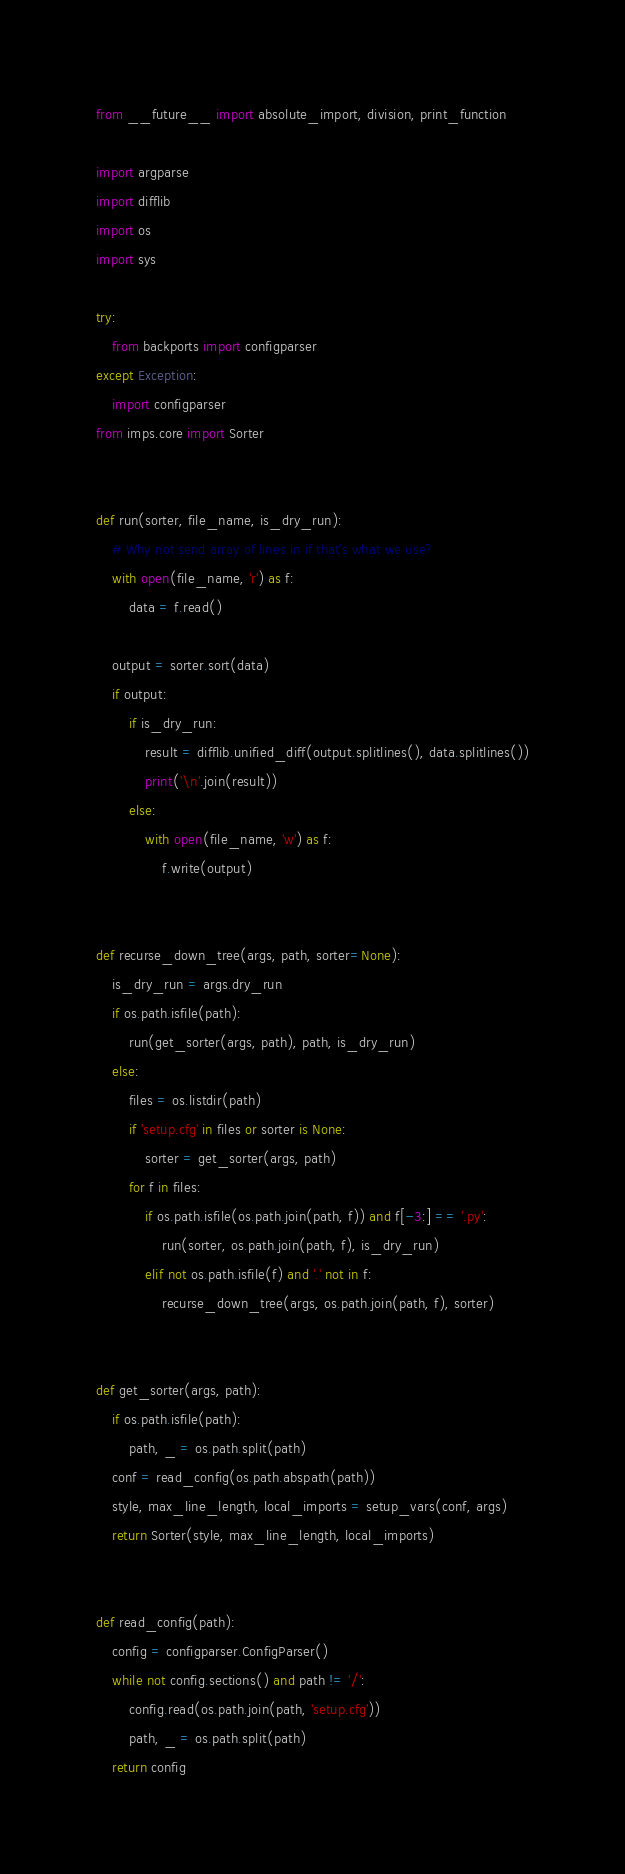Convert code to text. <code><loc_0><loc_0><loc_500><loc_500><_Python_>from __future__ import absolute_import, division, print_function

import argparse
import difflib
import os
import sys

try:
    from backports import configparser
except Exception:
    import configparser
from imps.core import Sorter


def run(sorter, file_name, is_dry_run):
    # Why not send array of lines in if that's what we use?
    with open(file_name, 'r') as f:
        data = f.read()

    output = sorter.sort(data)
    if output:
        if is_dry_run:
            result = difflib.unified_diff(output.splitlines(), data.splitlines())
            print('\n'.join(result))
        else:
            with open(file_name, 'w') as f:
                f.write(output)


def recurse_down_tree(args, path, sorter=None):
    is_dry_run = args.dry_run
    if os.path.isfile(path):
        run(get_sorter(args, path), path, is_dry_run)
    else:
        files = os.listdir(path)
        if 'setup.cfg' in files or sorter is None:
            sorter = get_sorter(args, path)
        for f in files:
            if os.path.isfile(os.path.join(path, f)) and f[-3:] == '.py':
                run(sorter, os.path.join(path, f), is_dry_run)
            elif not os.path.isfile(f) and '.' not in f:
                recurse_down_tree(args, os.path.join(path, f), sorter)


def get_sorter(args, path):
    if os.path.isfile(path):
        path, _ = os.path.split(path)
    conf = read_config(os.path.abspath(path))
    style, max_line_length, local_imports = setup_vars(conf, args)
    return Sorter(style, max_line_length, local_imports)


def read_config(path):
    config = configparser.ConfigParser()
    while not config.sections() and path != '/':
        config.read(os.path.join(path, 'setup.cfg'))
        path, _ = os.path.split(path)
    return config

</code> 